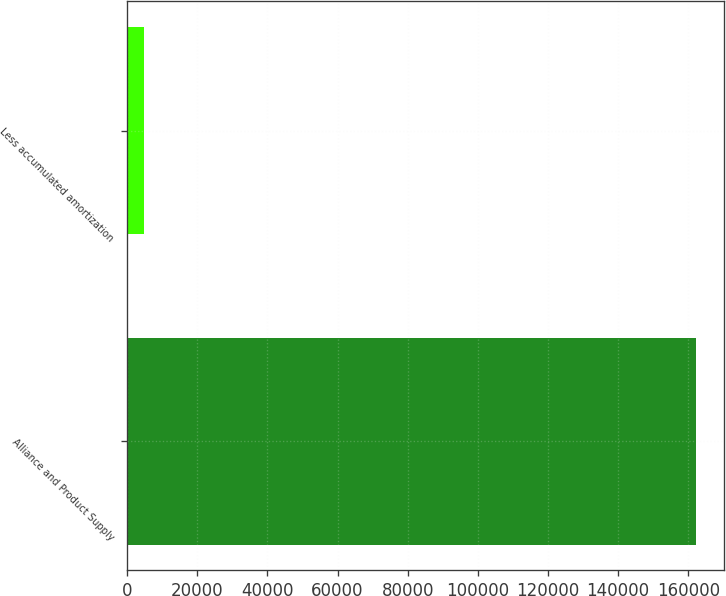<chart> <loc_0><loc_0><loc_500><loc_500><bar_chart><fcel>Alliance and Product Supply<fcel>Less accumulated amortization<nl><fcel>162100<fcel>4856<nl></chart> 